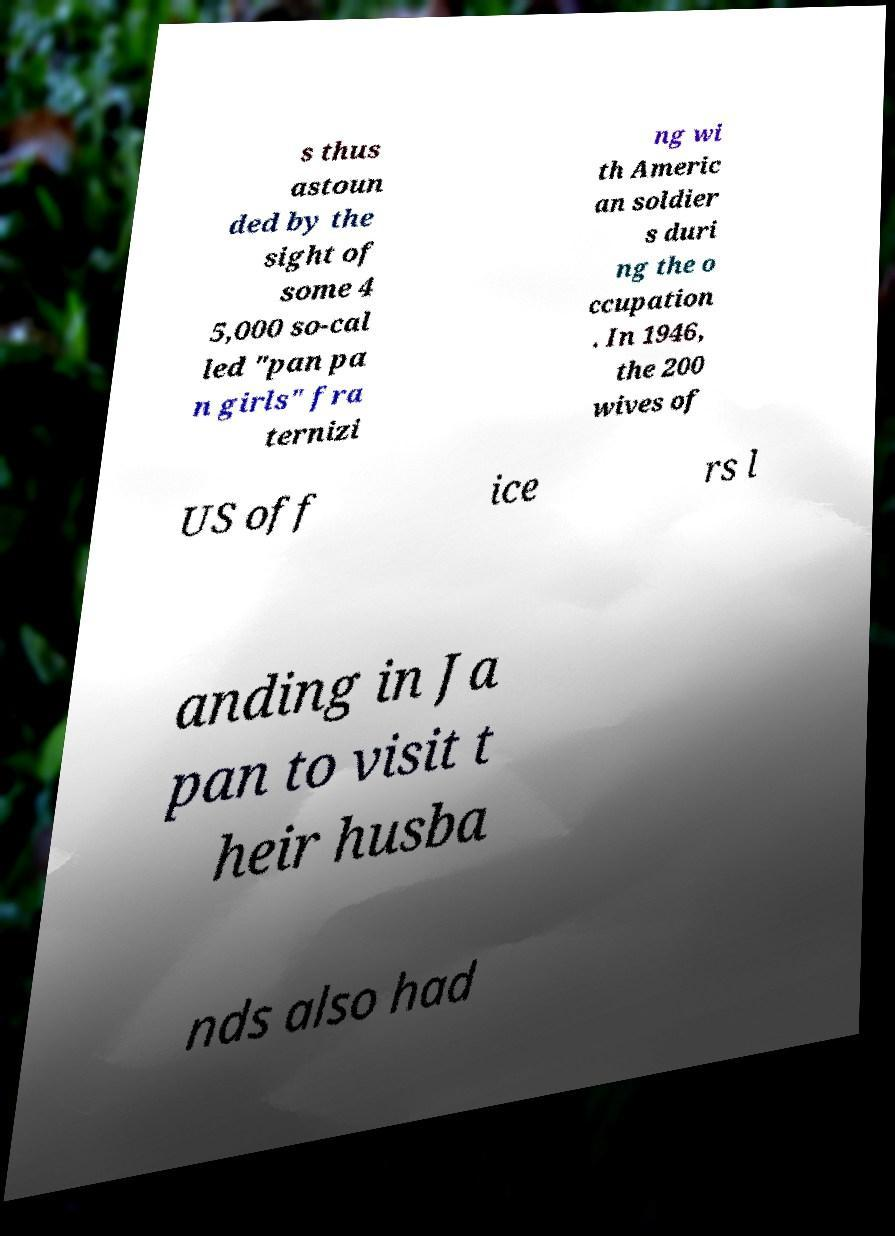Could you extract and type out the text from this image? s thus astoun ded by the sight of some 4 5,000 so-cal led "pan pa n girls" fra ternizi ng wi th Americ an soldier s duri ng the o ccupation . In 1946, the 200 wives of US off ice rs l anding in Ja pan to visit t heir husba nds also had 